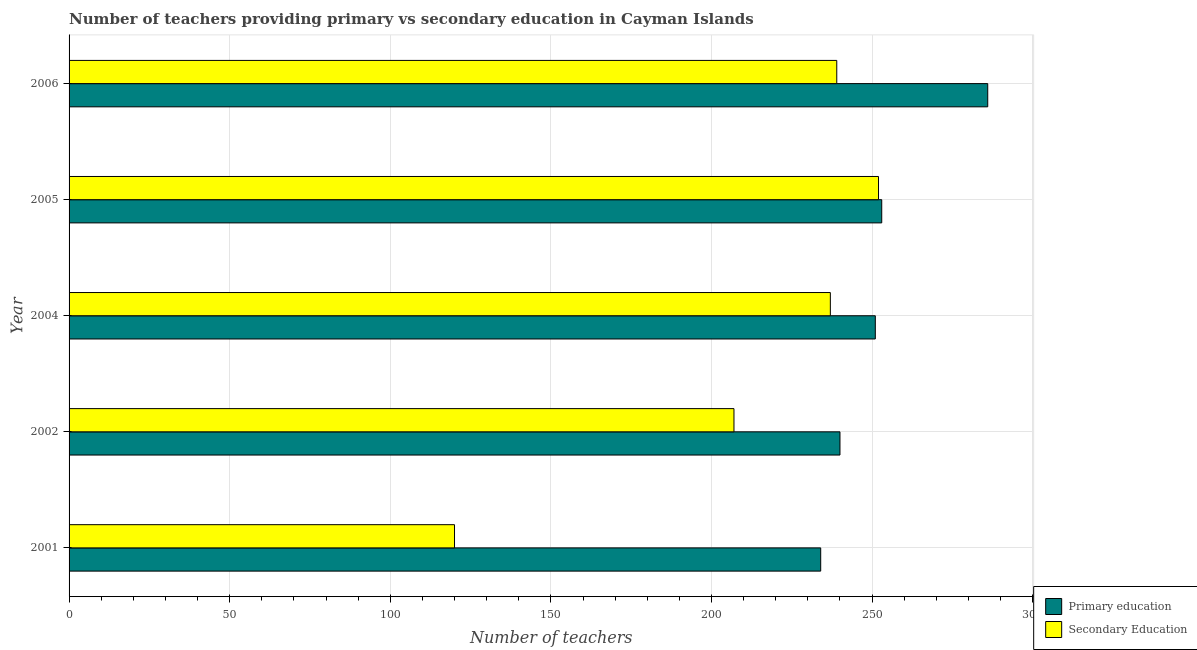How many different coloured bars are there?
Offer a terse response. 2. How many bars are there on the 4th tick from the top?
Offer a terse response. 2. What is the label of the 2nd group of bars from the top?
Give a very brief answer. 2005. What is the number of secondary teachers in 2002?
Your answer should be compact. 207. Across all years, what is the maximum number of primary teachers?
Your response must be concise. 286. Across all years, what is the minimum number of primary teachers?
Provide a succinct answer. 234. In which year was the number of primary teachers maximum?
Make the answer very short. 2006. What is the total number of secondary teachers in the graph?
Your response must be concise. 1055. What is the difference between the number of secondary teachers in 2005 and that in 2006?
Your response must be concise. 13. What is the difference between the number of secondary teachers in 2002 and the number of primary teachers in 2006?
Make the answer very short. -79. What is the average number of secondary teachers per year?
Ensure brevity in your answer.  211. In the year 2004, what is the difference between the number of primary teachers and number of secondary teachers?
Provide a short and direct response. 14. In how many years, is the number of primary teachers greater than 120 ?
Make the answer very short. 5. What is the ratio of the number of secondary teachers in 2004 to that in 2005?
Make the answer very short. 0.94. Is the difference between the number of secondary teachers in 2004 and 2006 greater than the difference between the number of primary teachers in 2004 and 2006?
Offer a very short reply. Yes. What is the difference between the highest and the second highest number of secondary teachers?
Make the answer very short. 13. What is the difference between the highest and the lowest number of primary teachers?
Offer a very short reply. 52. In how many years, is the number of secondary teachers greater than the average number of secondary teachers taken over all years?
Make the answer very short. 3. Is the sum of the number of primary teachers in 2001 and 2002 greater than the maximum number of secondary teachers across all years?
Offer a terse response. Yes. What does the 1st bar from the top in 2005 represents?
Give a very brief answer. Secondary Education. What does the 2nd bar from the bottom in 2006 represents?
Provide a succinct answer. Secondary Education. How many years are there in the graph?
Your answer should be compact. 5. Does the graph contain grids?
Ensure brevity in your answer.  Yes. Where does the legend appear in the graph?
Offer a terse response. Bottom right. How many legend labels are there?
Give a very brief answer. 2. What is the title of the graph?
Offer a terse response. Number of teachers providing primary vs secondary education in Cayman Islands. Does "Depositors" appear as one of the legend labels in the graph?
Provide a short and direct response. No. What is the label or title of the X-axis?
Offer a very short reply. Number of teachers. What is the Number of teachers in Primary education in 2001?
Offer a terse response. 234. What is the Number of teachers of Secondary Education in 2001?
Your answer should be compact. 120. What is the Number of teachers of Primary education in 2002?
Your answer should be very brief. 240. What is the Number of teachers of Secondary Education in 2002?
Make the answer very short. 207. What is the Number of teachers in Primary education in 2004?
Give a very brief answer. 251. What is the Number of teachers of Secondary Education in 2004?
Ensure brevity in your answer.  237. What is the Number of teachers in Primary education in 2005?
Offer a terse response. 253. What is the Number of teachers of Secondary Education in 2005?
Provide a short and direct response. 252. What is the Number of teachers of Primary education in 2006?
Your answer should be very brief. 286. What is the Number of teachers of Secondary Education in 2006?
Provide a short and direct response. 239. Across all years, what is the maximum Number of teachers in Primary education?
Provide a succinct answer. 286. Across all years, what is the maximum Number of teachers of Secondary Education?
Make the answer very short. 252. Across all years, what is the minimum Number of teachers of Primary education?
Ensure brevity in your answer.  234. Across all years, what is the minimum Number of teachers of Secondary Education?
Ensure brevity in your answer.  120. What is the total Number of teachers of Primary education in the graph?
Offer a very short reply. 1264. What is the total Number of teachers in Secondary Education in the graph?
Provide a succinct answer. 1055. What is the difference between the Number of teachers of Secondary Education in 2001 and that in 2002?
Your answer should be very brief. -87. What is the difference between the Number of teachers of Primary education in 2001 and that in 2004?
Offer a very short reply. -17. What is the difference between the Number of teachers in Secondary Education in 2001 and that in 2004?
Provide a succinct answer. -117. What is the difference between the Number of teachers of Secondary Education in 2001 and that in 2005?
Ensure brevity in your answer.  -132. What is the difference between the Number of teachers in Primary education in 2001 and that in 2006?
Give a very brief answer. -52. What is the difference between the Number of teachers in Secondary Education in 2001 and that in 2006?
Keep it short and to the point. -119. What is the difference between the Number of teachers of Primary education in 2002 and that in 2004?
Give a very brief answer. -11. What is the difference between the Number of teachers in Primary education in 2002 and that in 2005?
Provide a succinct answer. -13. What is the difference between the Number of teachers in Secondary Education in 2002 and that in 2005?
Give a very brief answer. -45. What is the difference between the Number of teachers of Primary education in 2002 and that in 2006?
Provide a succinct answer. -46. What is the difference between the Number of teachers in Secondary Education in 2002 and that in 2006?
Ensure brevity in your answer.  -32. What is the difference between the Number of teachers in Primary education in 2004 and that in 2005?
Make the answer very short. -2. What is the difference between the Number of teachers in Primary education in 2004 and that in 2006?
Make the answer very short. -35. What is the difference between the Number of teachers in Secondary Education in 2004 and that in 2006?
Keep it short and to the point. -2. What is the difference between the Number of teachers in Primary education in 2005 and that in 2006?
Offer a terse response. -33. What is the difference between the Number of teachers in Primary education in 2001 and the Number of teachers in Secondary Education in 2004?
Give a very brief answer. -3. What is the difference between the Number of teachers in Primary education in 2002 and the Number of teachers in Secondary Education in 2005?
Provide a short and direct response. -12. What is the difference between the Number of teachers in Primary education in 2004 and the Number of teachers in Secondary Education in 2005?
Provide a succinct answer. -1. What is the difference between the Number of teachers of Primary education in 2004 and the Number of teachers of Secondary Education in 2006?
Your answer should be very brief. 12. What is the average Number of teachers in Primary education per year?
Offer a terse response. 252.8. What is the average Number of teachers of Secondary Education per year?
Make the answer very short. 211. In the year 2001, what is the difference between the Number of teachers in Primary education and Number of teachers in Secondary Education?
Provide a succinct answer. 114. In the year 2002, what is the difference between the Number of teachers in Primary education and Number of teachers in Secondary Education?
Your answer should be very brief. 33. In the year 2006, what is the difference between the Number of teachers in Primary education and Number of teachers in Secondary Education?
Ensure brevity in your answer.  47. What is the ratio of the Number of teachers in Secondary Education in 2001 to that in 2002?
Your answer should be very brief. 0.58. What is the ratio of the Number of teachers in Primary education in 2001 to that in 2004?
Offer a terse response. 0.93. What is the ratio of the Number of teachers of Secondary Education in 2001 to that in 2004?
Offer a very short reply. 0.51. What is the ratio of the Number of teachers of Primary education in 2001 to that in 2005?
Offer a very short reply. 0.92. What is the ratio of the Number of teachers in Secondary Education in 2001 to that in 2005?
Offer a very short reply. 0.48. What is the ratio of the Number of teachers of Primary education in 2001 to that in 2006?
Keep it short and to the point. 0.82. What is the ratio of the Number of teachers of Secondary Education in 2001 to that in 2006?
Your response must be concise. 0.5. What is the ratio of the Number of teachers of Primary education in 2002 to that in 2004?
Provide a short and direct response. 0.96. What is the ratio of the Number of teachers in Secondary Education in 2002 to that in 2004?
Give a very brief answer. 0.87. What is the ratio of the Number of teachers of Primary education in 2002 to that in 2005?
Your response must be concise. 0.95. What is the ratio of the Number of teachers of Secondary Education in 2002 to that in 2005?
Offer a terse response. 0.82. What is the ratio of the Number of teachers in Primary education in 2002 to that in 2006?
Your response must be concise. 0.84. What is the ratio of the Number of teachers in Secondary Education in 2002 to that in 2006?
Offer a very short reply. 0.87. What is the ratio of the Number of teachers in Primary education in 2004 to that in 2005?
Provide a short and direct response. 0.99. What is the ratio of the Number of teachers of Secondary Education in 2004 to that in 2005?
Offer a very short reply. 0.94. What is the ratio of the Number of teachers in Primary education in 2004 to that in 2006?
Your answer should be compact. 0.88. What is the ratio of the Number of teachers of Secondary Education in 2004 to that in 2006?
Ensure brevity in your answer.  0.99. What is the ratio of the Number of teachers of Primary education in 2005 to that in 2006?
Keep it short and to the point. 0.88. What is the ratio of the Number of teachers in Secondary Education in 2005 to that in 2006?
Provide a succinct answer. 1.05. What is the difference between the highest and the lowest Number of teachers of Secondary Education?
Offer a terse response. 132. 